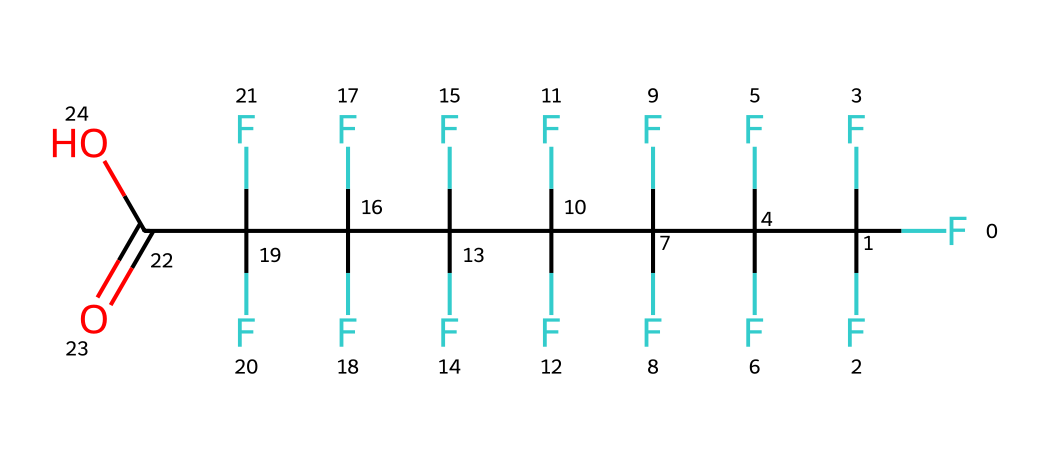What is the main functional group in this chemical structure? The chemical structure has a carboxylic acid functional group indicated by the -COOH part at the end of the structure. This group is characterized by the presence of a carbon atom double-bonded to an oxygen atom and single-bonded to a hydroxyl group (-OH).
Answer: carboxylic acid How many carbon atoms are present in this molecule? By examining the structure, we can count the number of carbon atoms present. The chain shows a total of eight carbon atoms, which includes the carboxylic acid carbon.
Answer: eight What type of chemical is PFOA categorized as? PFOA is categorized as a perfluoroalkyl substance. This classification comes from the fact that it contains a long chain of carbon atoms fully substituted by fluorine atoms, in addition to having a functional group.
Answer: perfluoroalkyl substance What characteristic property is associated with the fluorinated carbon backbone of PFOA? The fluorinated carbon backbone provides unique properties such as water, oil, and stain resistance. This is due to the strong C-F bonds that contribute to the hydrophobic nature of the molecule.
Answer: hydrophobic What is the total number of fluorine atoms in the chemical? By inspecting the structure, there are a total of fifteen fluorine atoms attached to the carbon chain. Each of the carbon atoms except the one with the carboxylic acid group is fully substituted with fluorine.
Answer: fifteen How does the presence of the carbonyl group influence the behavior of PFOA? The carbonyl group increases the molecule's ability to interact with other substances through hydrogen bonding, making it more reactive compared to typical perfluorinated compounds that do not have such groups.
Answer: increases reactivity 